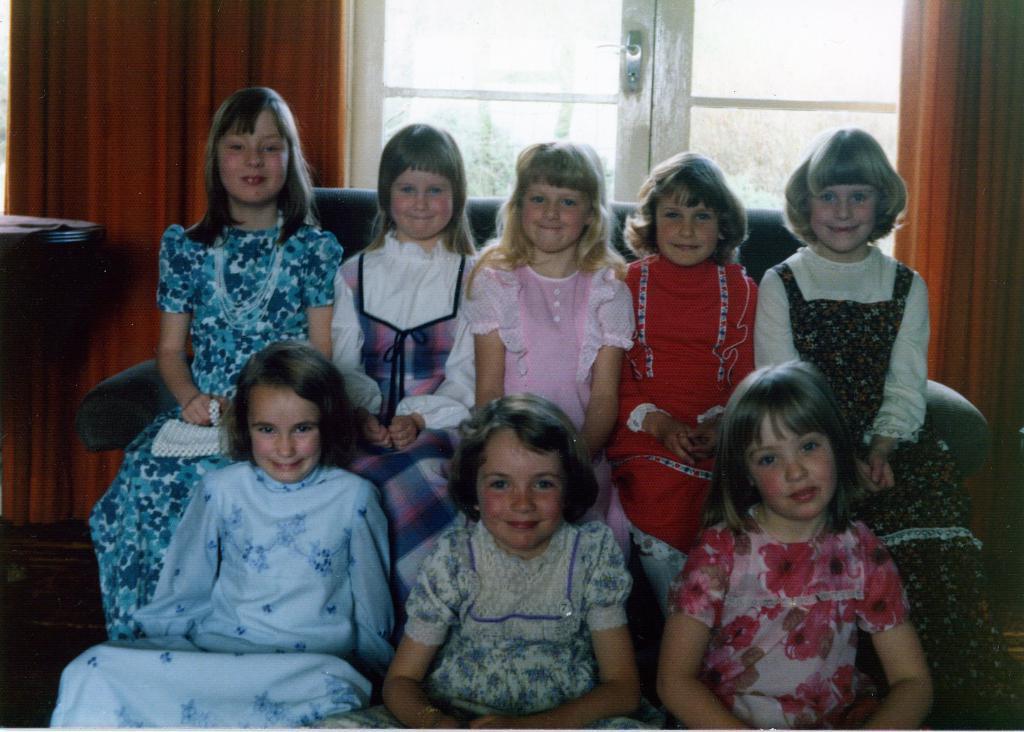How would you summarize this image in a sentence or two? This image consists of eight girls sitting in a room. Five are sitting on the couch and three are sitting on the floor. On the left, there is a table. 